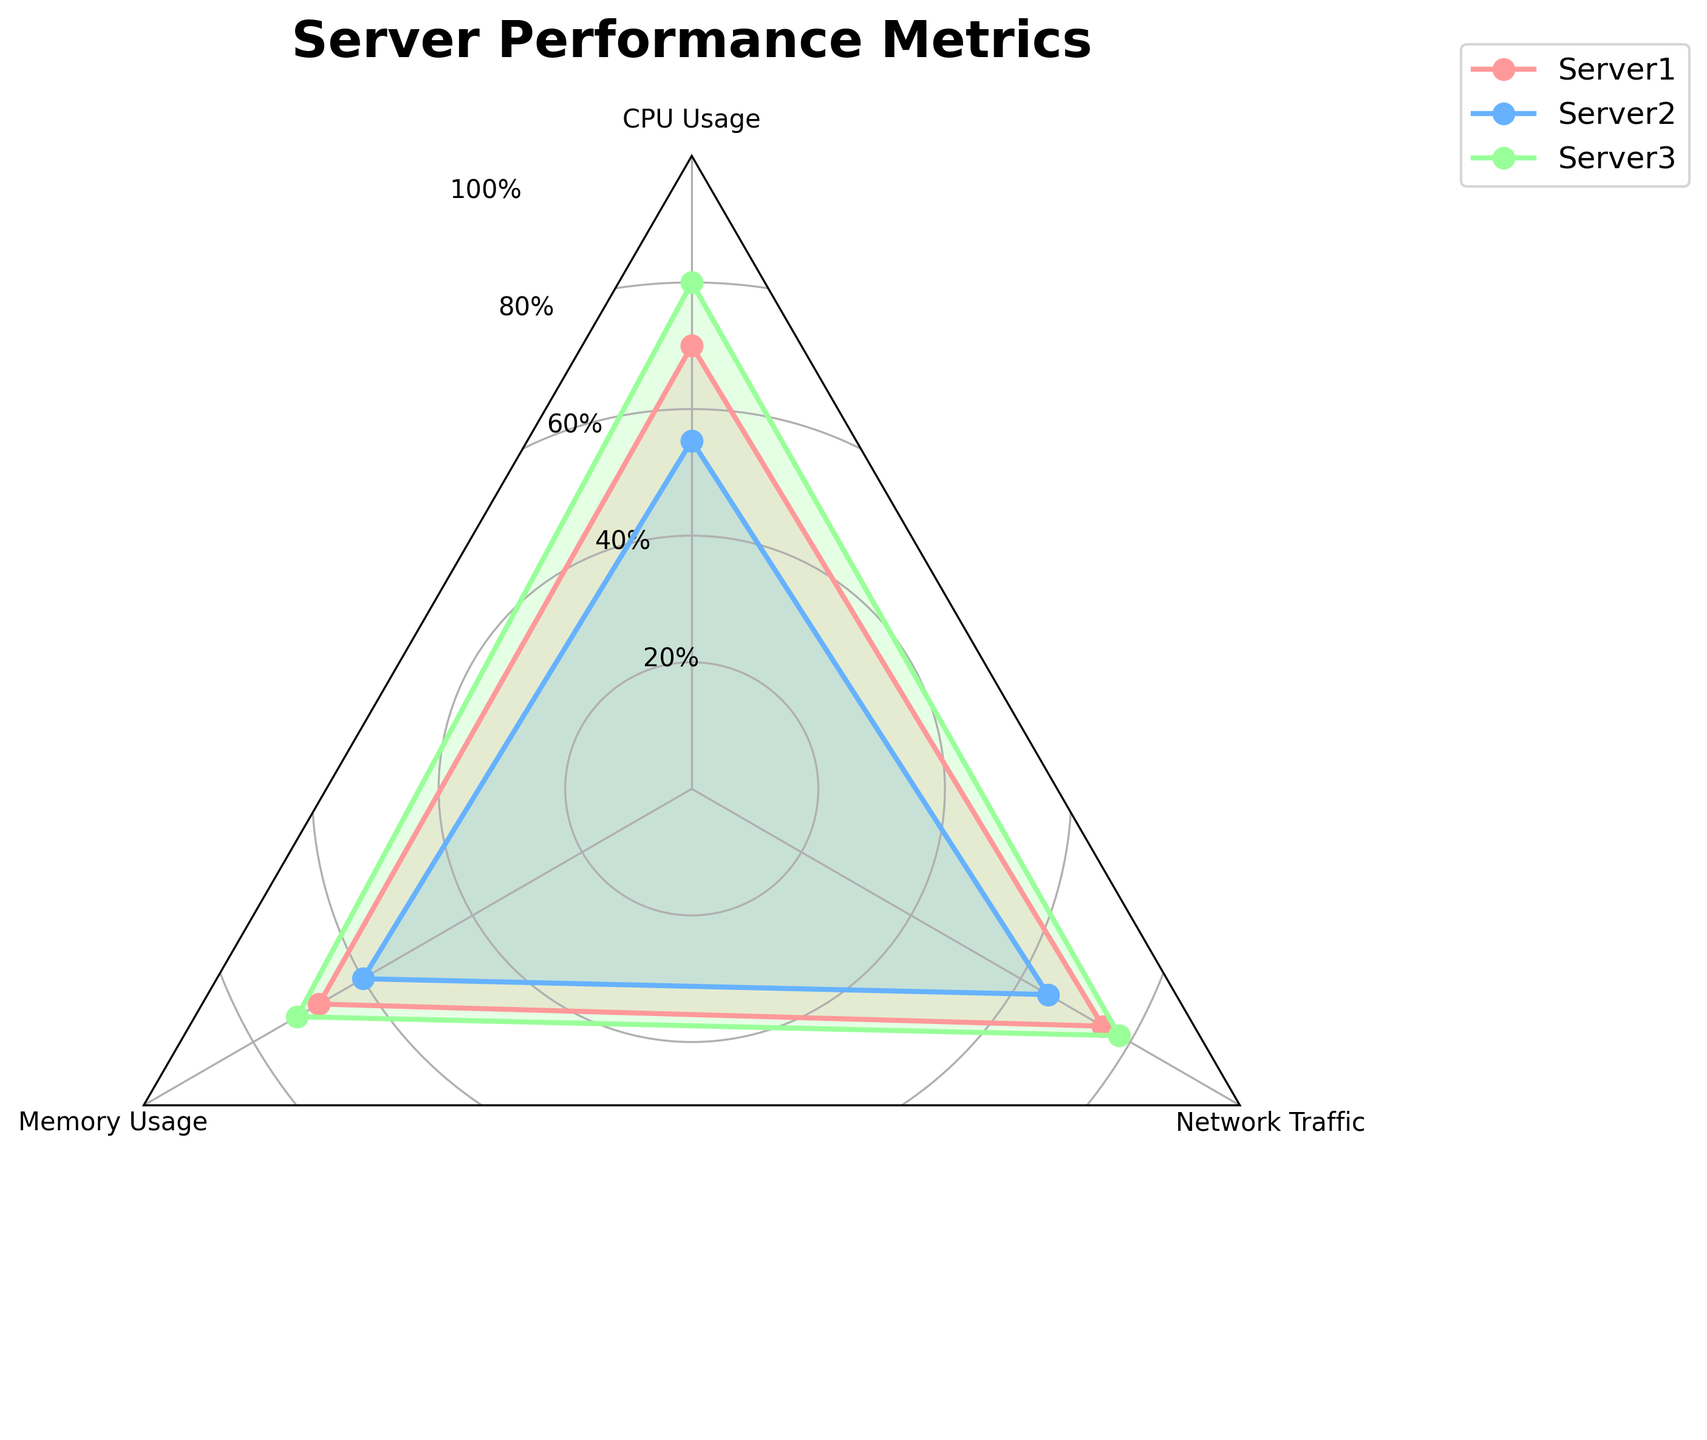What is the title of the radar chart? The title is usually located at the top of the chart. In this case, it reads "Server Performance Metrics".
Answer: Server Performance Metrics Which server has the highest CPU Usage? By looking at the 'CPU Usage' point on the radar chart, Server 3 has the highest value at 80%.
Answer: Server 3 What is the average Memory Usage across all servers? To find the average: (Server 1 Memory Usage + Server 2 Memory Usage + Server 3 Memory Usage) / 3 = (68 + 60 + 72) / 3 = 200 / 3 = 66.67
Answer: 66.67 How does the Network Traffic of Server 2 compare to Server 1? Server 2 has a Network Traffic of 65% while Server 1 has 75%. Therefore, Server 2's Network Traffic is 10% less than Server 1.
Answer: 10% less Which performance metric generally has the least variation among servers? By comparing the spread of values in each performance metric (CPU Usage: 55-80, Memory Usage: 60-72, Network Traffic: 65-78), Memory Usage has the least variation (60 to 72).
Answer: Memory Usage Is there any performance metric where all servers score above 60%? Checking each metric: CPU Usage (55% for Server 2), Memory Usage (all above 60%), Network Traffic (all above 60%). So, Memory Usage and Network Traffic have all servers scoring above 60%.
Answer: Memory Usage, Network Traffic What is the performance trend for Server 3 across all metrics? Server 3 shows high performance across all metrics with scores of 80% (CPU Usage), 72% (Memory Usage), and 78% (Network Traffic).
Answer: High performance across all metrics Which server shows the most balanced performance across all metrics? By looking at the chart, Server 1 seems to have values that are more closely clustered around each other (70% CPU Usage, 68% Memory Usage, 75% Network Traffic) indicating a balanced performance.
Answer: Server 1 What is the median value of Network Traffic across all servers? Sorting the Network Traffic values (75, 65, 78), the median value is the middle number, which is 75.
Answer: 75 